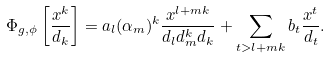Convert formula to latex. <formula><loc_0><loc_0><loc_500><loc_500>\Phi _ { g , \phi } \left [ \frac { x ^ { k } } { d _ { k } } \right ] = a _ { l } ( \alpha _ { m } ) ^ { k } \frac { x ^ { l + m k } } { d _ { l } d _ { m } ^ { k } d _ { k } } + \sum _ { t > l + m k } b _ { t } \frac { x ^ { t } } { d _ { t } } .</formula> 